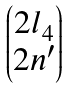<formula> <loc_0><loc_0><loc_500><loc_500>\begin{pmatrix} 2 l _ { 4 } \\ 2 n ^ { \prime } \end{pmatrix}</formula> 